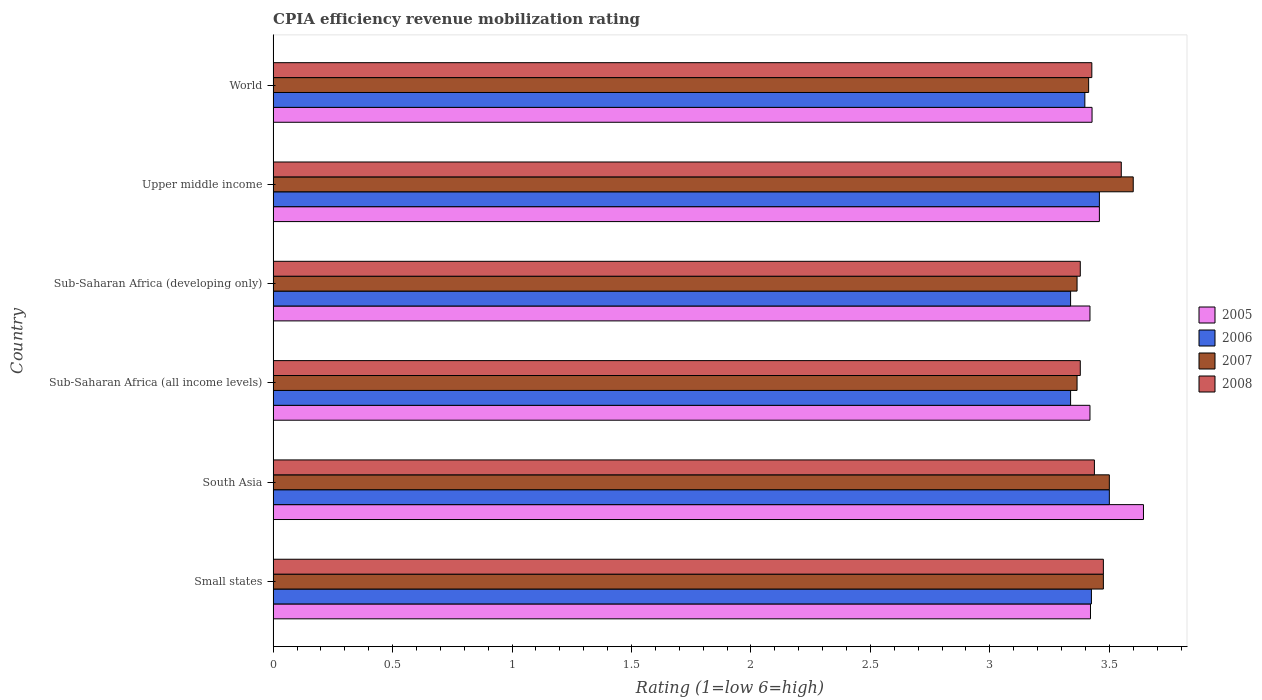How many groups of bars are there?
Provide a succinct answer. 6. Are the number of bars per tick equal to the number of legend labels?
Offer a very short reply. Yes. How many bars are there on the 5th tick from the top?
Keep it short and to the point. 4. What is the label of the 4th group of bars from the top?
Your answer should be very brief. Sub-Saharan Africa (all income levels). In how many cases, is the number of bars for a given country not equal to the number of legend labels?
Ensure brevity in your answer.  0. What is the CPIA rating in 2005 in Small states?
Provide a succinct answer. 3.42. Across all countries, what is the maximum CPIA rating in 2008?
Ensure brevity in your answer.  3.55. Across all countries, what is the minimum CPIA rating in 2008?
Provide a short and direct response. 3.38. In which country was the CPIA rating in 2007 maximum?
Your response must be concise. Upper middle income. In which country was the CPIA rating in 2008 minimum?
Your response must be concise. Sub-Saharan Africa (all income levels). What is the total CPIA rating in 2008 in the graph?
Your response must be concise. 20.65. What is the difference between the CPIA rating in 2007 in Small states and that in Sub-Saharan Africa (developing only)?
Provide a succinct answer. 0.11. What is the difference between the CPIA rating in 2008 in Small states and the CPIA rating in 2005 in Upper middle income?
Offer a very short reply. 0.02. What is the average CPIA rating in 2008 per country?
Keep it short and to the point. 3.44. What is the difference between the CPIA rating in 2007 and CPIA rating in 2005 in Small states?
Offer a terse response. 0.05. In how many countries, is the CPIA rating in 2006 greater than 1.3 ?
Make the answer very short. 6. What is the ratio of the CPIA rating in 2008 in South Asia to that in Sub-Saharan Africa (all income levels)?
Offer a terse response. 1.02. What is the difference between the highest and the second highest CPIA rating in 2008?
Keep it short and to the point. 0.07. What is the difference between the highest and the lowest CPIA rating in 2008?
Give a very brief answer. 0.17. In how many countries, is the CPIA rating in 2008 greater than the average CPIA rating in 2008 taken over all countries?
Offer a very short reply. 2. Is it the case that in every country, the sum of the CPIA rating in 2006 and CPIA rating in 2008 is greater than the sum of CPIA rating in 2007 and CPIA rating in 2005?
Make the answer very short. No. What does the 4th bar from the top in Sub-Saharan Africa (all income levels) represents?
Your response must be concise. 2005. What does the 3rd bar from the bottom in Small states represents?
Your response must be concise. 2007. Are all the bars in the graph horizontal?
Ensure brevity in your answer.  Yes. How many countries are there in the graph?
Make the answer very short. 6. What is the difference between two consecutive major ticks on the X-axis?
Offer a very short reply. 0.5. Are the values on the major ticks of X-axis written in scientific E-notation?
Give a very brief answer. No. Does the graph contain any zero values?
Your answer should be compact. No. Where does the legend appear in the graph?
Make the answer very short. Center right. How many legend labels are there?
Give a very brief answer. 4. What is the title of the graph?
Make the answer very short. CPIA efficiency revenue mobilization rating. Does "2009" appear as one of the legend labels in the graph?
Ensure brevity in your answer.  No. What is the Rating (1=low 6=high) in 2005 in Small states?
Make the answer very short. 3.42. What is the Rating (1=low 6=high) of 2006 in Small states?
Your answer should be compact. 3.42. What is the Rating (1=low 6=high) of 2007 in Small states?
Give a very brief answer. 3.48. What is the Rating (1=low 6=high) of 2008 in Small states?
Give a very brief answer. 3.48. What is the Rating (1=low 6=high) in 2005 in South Asia?
Provide a short and direct response. 3.64. What is the Rating (1=low 6=high) in 2006 in South Asia?
Provide a short and direct response. 3.5. What is the Rating (1=low 6=high) in 2008 in South Asia?
Ensure brevity in your answer.  3.44. What is the Rating (1=low 6=high) in 2005 in Sub-Saharan Africa (all income levels)?
Your response must be concise. 3.42. What is the Rating (1=low 6=high) of 2006 in Sub-Saharan Africa (all income levels)?
Your answer should be very brief. 3.34. What is the Rating (1=low 6=high) of 2007 in Sub-Saharan Africa (all income levels)?
Make the answer very short. 3.36. What is the Rating (1=low 6=high) in 2008 in Sub-Saharan Africa (all income levels)?
Provide a short and direct response. 3.38. What is the Rating (1=low 6=high) of 2005 in Sub-Saharan Africa (developing only)?
Give a very brief answer. 3.42. What is the Rating (1=low 6=high) of 2006 in Sub-Saharan Africa (developing only)?
Make the answer very short. 3.34. What is the Rating (1=low 6=high) of 2007 in Sub-Saharan Africa (developing only)?
Keep it short and to the point. 3.36. What is the Rating (1=low 6=high) of 2008 in Sub-Saharan Africa (developing only)?
Your answer should be compact. 3.38. What is the Rating (1=low 6=high) of 2005 in Upper middle income?
Provide a succinct answer. 3.46. What is the Rating (1=low 6=high) in 2006 in Upper middle income?
Give a very brief answer. 3.46. What is the Rating (1=low 6=high) in 2007 in Upper middle income?
Make the answer very short. 3.6. What is the Rating (1=low 6=high) in 2008 in Upper middle income?
Ensure brevity in your answer.  3.55. What is the Rating (1=low 6=high) in 2005 in World?
Your response must be concise. 3.43. What is the Rating (1=low 6=high) in 2006 in World?
Make the answer very short. 3.4. What is the Rating (1=low 6=high) in 2007 in World?
Give a very brief answer. 3.41. What is the Rating (1=low 6=high) in 2008 in World?
Ensure brevity in your answer.  3.43. Across all countries, what is the maximum Rating (1=low 6=high) in 2005?
Your answer should be very brief. 3.64. Across all countries, what is the maximum Rating (1=low 6=high) of 2006?
Your answer should be compact. 3.5. Across all countries, what is the maximum Rating (1=low 6=high) of 2007?
Ensure brevity in your answer.  3.6. Across all countries, what is the maximum Rating (1=low 6=high) of 2008?
Keep it short and to the point. 3.55. Across all countries, what is the minimum Rating (1=low 6=high) of 2005?
Give a very brief answer. 3.42. Across all countries, what is the minimum Rating (1=low 6=high) in 2006?
Give a very brief answer. 3.34. Across all countries, what is the minimum Rating (1=low 6=high) in 2007?
Offer a very short reply. 3.36. Across all countries, what is the minimum Rating (1=low 6=high) in 2008?
Offer a very short reply. 3.38. What is the total Rating (1=low 6=high) of 2005 in the graph?
Provide a short and direct response. 20.79. What is the total Rating (1=low 6=high) in 2006 in the graph?
Offer a terse response. 20.46. What is the total Rating (1=low 6=high) of 2007 in the graph?
Offer a terse response. 20.72. What is the total Rating (1=low 6=high) of 2008 in the graph?
Provide a succinct answer. 20.65. What is the difference between the Rating (1=low 6=high) of 2005 in Small states and that in South Asia?
Keep it short and to the point. -0.22. What is the difference between the Rating (1=low 6=high) in 2006 in Small states and that in South Asia?
Give a very brief answer. -0.07. What is the difference between the Rating (1=low 6=high) in 2007 in Small states and that in South Asia?
Offer a very short reply. -0.03. What is the difference between the Rating (1=low 6=high) in 2008 in Small states and that in South Asia?
Give a very brief answer. 0.04. What is the difference between the Rating (1=low 6=high) in 2005 in Small states and that in Sub-Saharan Africa (all income levels)?
Provide a short and direct response. 0. What is the difference between the Rating (1=low 6=high) in 2006 in Small states and that in Sub-Saharan Africa (all income levels)?
Provide a succinct answer. 0.09. What is the difference between the Rating (1=low 6=high) in 2007 in Small states and that in Sub-Saharan Africa (all income levels)?
Your answer should be very brief. 0.11. What is the difference between the Rating (1=low 6=high) of 2008 in Small states and that in Sub-Saharan Africa (all income levels)?
Give a very brief answer. 0.1. What is the difference between the Rating (1=low 6=high) of 2005 in Small states and that in Sub-Saharan Africa (developing only)?
Your answer should be compact. 0. What is the difference between the Rating (1=low 6=high) in 2006 in Small states and that in Sub-Saharan Africa (developing only)?
Make the answer very short. 0.09. What is the difference between the Rating (1=low 6=high) of 2007 in Small states and that in Sub-Saharan Africa (developing only)?
Provide a short and direct response. 0.11. What is the difference between the Rating (1=low 6=high) in 2008 in Small states and that in Sub-Saharan Africa (developing only)?
Give a very brief answer. 0.1. What is the difference between the Rating (1=low 6=high) in 2005 in Small states and that in Upper middle income?
Offer a terse response. -0.04. What is the difference between the Rating (1=low 6=high) of 2006 in Small states and that in Upper middle income?
Provide a short and direct response. -0.03. What is the difference between the Rating (1=low 6=high) in 2007 in Small states and that in Upper middle income?
Your answer should be very brief. -0.12. What is the difference between the Rating (1=low 6=high) in 2008 in Small states and that in Upper middle income?
Your answer should be compact. -0.07. What is the difference between the Rating (1=low 6=high) of 2005 in Small states and that in World?
Your answer should be very brief. -0.01. What is the difference between the Rating (1=low 6=high) of 2006 in Small states and that in World?
Your answer should be very brief. 0.03. What is the difference between the Rating (1=low 6=high) in 2007 in Small states and that in World?
Your answer should be compact. 0.06. What is the difference between the Rating (1=low 6=high) in 2008 in Small states and that in World?
Keep it short and to the point. 0.05. What is the difference between the Rating (1=low 6=high) of 2005 in South Asia and that in Sub-Saharan Africa (all income levels)?
Your response must be concise. 0.22. What is the difference between the Rating (1=low 6=high) in 2006 in South Asia and that in Sub-Saharan Africa (all income levels)?
Ensure brevity in your answer.  0.16. What is the difference between the Rating (1=low 6=high) in 2007 in South Asia and that in Sub-Saharan Africa (all income levels)?
Keep it short and to the point. 0.14. What is the difference between the Rating (1=low 6=high) of 2008 in South Asia and that in Sub-Saharan Africa (all income levels)?
Give a very brief answer. 0.06. What is the difference between the Rating (1=low 6=high) in 2005 in South Asia and that in Sub-Saharan Africa (developing only)?
Make the answer very short. 0.22. What is the difference between the Rating (1=low 6=high) in 2006 in South Asia and that in Sub-Saharan Africa (developing only)?
Your answer should be very brief. 0.16. What is the difference between the Rating (1=low 6=high) of 2007 in South Asia and that in Sub-Saharan Africa (developing only)?
Ensure brevity in your answer.  0.14. What is the difference between the Rating (1=low 6=high) in 2008 in South Asia and that in Sub-Saharan Africa (developing only)?
Keep it short and to the point. 0.06. What is the difference between the Rating (1=low 6=high) in 2005 in South Asia and that in Upper middle income?
Ensure brevity in your answer.  0.18. What is the difference between the Rating (1=low 6=high) in 2006 in South Asia and that in Upper middle income?
Your answer should be very brief. 0.04. What is the difference between the Rating (1=low 6=high) of 2008 in South Asia and that in Upper middle income?
Provide a succinct answer. -0.11. What is the difference between the Rating (1=low 6=high) of 2005 in South Asia and that in World?
Keep it short and to the point. 0.22. What is the difference between the Rating (1=low 6=high) of 2006 in South Asia and that in World?
Your answer should be compact. 0.1. What is the difference between the Rating (1=low 6=high) in 2007 in South Asia and that in World?
Your answer should be compact. 0.09. What is the difference between the Rating (1=low 6=high) of 2008 in South Asia and that in World?
Ensure brevity in your answer.  0.01. What is the difference between the Rating (1=low 6=high) in 2006 in Sub-Saharan Africa (all income levels) and that in Sub-Saharan Africa (developing only)?
Ensure brevity in your answer.  0. What is the difference between the Rating (1=low 6=high) in 2008 in Sub-Saharan Africa (all income levels) and that in Sub-Saharan Africa (developing only)?
Provide a succinct answer. 0. What is the difference between the Rating (1=low 6=high) in 2005 in Sub-Saharan Africa (all income levels) and that in Upper middle income?
Keep it short and to the point. -0.04. What is the difference between the Rating (1=low 6=high) in 2006 in Sub-Saharan Africa (all income levels) and that in Upper middle income?
Keep it short and to the point. -0.12. What is the difference between the Rating (1=low 6=high) of 2007 in Sub-Saharan Africa (all income levels) and that in Upper middle income?
Your answer should be compact. -0.24. What is the difference between the Rating (1=low 6=high) of 2008 in Sub-Saharan Africa (all income levels) and that in Upper middle income?
Offer a terse response. -0.17. What is the difference between the Rating (1=low 6=high) in 2005 in Sub-Saharan Africa (all income levels) and that in World?
Your response must be concise. -0.01. What is the difference between the Rating (1=low 6=high) in 2006 in Sub-Saharan Africa (all income levels) and that in World?
Provide a short and direct response. -0.06. What is the difference between the Rating (1=low 6=high) of 2007 in Sub-Saharan Africa (all income levels) and that in World?
Your answer should be very brief. -0.05. What is the difference between the Rating (1=low 6=high) in 2008 in Sub-Saharan Africa (all income levels) and that in World?
Make the answer very short. -0.05. What is the difference between the Rating (1=low 6=high) of 2005 in Sub-Saharan Africa (developing only) and that in Upper middle income?
Your response must be concise. -0.04. What is the difference between the Rating (1=low 6=high) in 2006 in Sub-Saharan Africa (developing only) and that in Upper middle income?
Offer a very short reply. -0.12. What is the difference between the Rating (1=low 6=high) in 2007 in Sub-Saharan Africa (developing only) and that in Upper middle income?
Keep it short and to the point. -0.24. What is the difference between the Rating (1=low 6=high) of 2008 in Sub-Saharan Africa (developing only) and that in Upper middle income?
Offer a very short reply. -0.17. What is the difference between the Rating (1=low 6=high) in 2005 in Sub-Saharan Africa (developing only) and that in World?
Offer a very short reply. -0.01. What is the difference between the Rating (1=low 6=high) of 2006 in Sub-Saharan Africa (developing only) and that in World?
Provide a short and direct response. -0.06. What is the difference between the Rating (1=low 6=high) in 2007 in Sub-Saharan Africa (developing only) and that in World?
Give a very brief answer. -0.05. What is the difference between the Rating (1=low 6=high) in 2008 in Sub-Saharan Africa (developing only) and that in World?
Make the answer very short. -0.05. What is the difference between the Rating (1=low 6=high) of 2005 in Upper middle income and that in World?
Your answer should be compact. 0.03. What is the difference between the Rating (1=low 6=high) of 2006 in Upper middle income and that in World?
Offer a very short reply. 0.06. What is the difference between the Rating (1=low 6=high) in 2007 in Upper middle income and that in World?
Your answer should be very brief. 0.19. What is the difference between the Rating (1=low 6=high) of 2008 in Upper middle income and that in World?
Give a very brief answer. 0.12. What is the difference between the Rating (1=low 6=high) of 2005 in Small states and the Rating (1=low 6=high) of 2006 in South Asia?
Provide a succinct answer. -0.08. What is the difference between the Rating (1=low 6=high) of 2005 in Small states and the Rating (1=low 6=high) of 2007 in South Asia?
Your answer should be compact. -0.08. What is the difference between the Rating (1=low 6=high) of 2005 in Small states and the Rating (1=low 6=high) of 2008 in South Asia?
Provide a succinct answer. -0.02. What is the difference between the Rating (1=low 6=high) in 2006 in Small states and the Rating (1=low 6=high) in 2007 in South Asia?
Your answer should be compact. -0.07. What is the difference between the Rating (1=low 6=high) in 2006 in Small states and the Rating (1=low 6=high) in 2008 in South Asia?
Provide a short and direct response. -0.01. What is the difference between the Rating (1=low 6=high) of 2007 in Small states and the Rating (1=low 6=high) of 2008 in South Asia?
Ensure brevity in your answer.  0.04. What is the difference between the Rating (1=low 6=high) in 2005 in Small states and the Rating (1=low 6=high) in 2006 in Sub-Saharan Africa (all income levels)?
Offer a terse response. 0.08. What is the difference between the Rating (1=low 6=high) in 2005 in Small states and the Rating (1=low 6=high) in 2007 in Sub-Saharan Africa (all income levels)?
Ensure brevity in your answer.  0.06. What is the difference between the Rating (1=low 6=high) in 2005 in Small states and the Rating (1=low 6=high) in 2008 in Sub-Saharan Africa (all income levels)?
Ensure brevity in your answer.  0.04. What is the difference between the Rating (1=low 6=high) of 2006 in Small states and the Rating (1=low 6=high) of 2007 in Sub-Saharan Africa (all income levels)?
Provide a succinct answer. 0.06. What is the difference between the Rating (1=low 6=high) of 2006 in Small states and the Rating (1=low 6=high) of 2008 in Sub-Saharan Africa (all income levels)?
Offer a terse response. 0.05. What is the difference between the Rating (1=low 6=high) of 2007 in Small states and the Rating (1=low 6=high) of 2008 in Sub-Saharan Africa (all income levels)?
Provide a short and direct response. 0.1. What is the difference between the Rating (1=low 6=high) of 2005 in Small states and the Rating (1=low 6=high) of 2006 in Sub-Saharan Africa (developing only)?
Ensure brevity in your answer.  0.08. What is the difference between the Rating (1=low 6=high) in 2005 in Small states and the Rating (1=low 6=high) in 2007 in Sub-Saharan Africa (developing only)?
Your response must be concise. 0.06. What is the difference between the Rating (1=low 6=high) of 2005 in Small states and the Rating (1=low 6=high) of 2008 in Sub-Saharan Africa (developing only)?
Offer a terse response. 0.04. What is the difference between the Rating (1=low 6=high) in 2006 in Small states and the Rating (1=low 6=high) in 2007 in Sub-Saharan Africa (developing only)?
Your answer should be compact. 0.06. What is the difference between the Rating (1=low 6=high) of 2006 in Small states and the Rating (1=low 6=high) of 2008 in Sub-Saharan Africa (developing only)?
Give a very brief answer. 0.05. What is the difference between the Rating (1=low 6=high) in 2007 in Small states and the Rating (1=low 6=high) in 2008 in Sub-Saharan Africa (developing only)?
Offer a very short reply. 0.1. What is the difference between the Rating (1=low 6=high) in 2005 in Small states and the Rating (1=low 6=high) in 2006 in Upper middle income?
Provide a succinct answer. -0.04. What is the difference between the Rating (1=low 6=high) of 2005 in Small states and the Rating (1=low 6=high) of 2007 in Upper middle income?
Ensure brevity in your answer.  -0.18. What is the difference between the Rating (1=low 6=high) of 2005 in Small states and the Rating (1=low 6=high) of 2008 in Upper middle income?
Your response must be concise. -0.13. What is the difference between the Rating (1=low 6=high) of 2006 in Small states and the Rating (1=low 6=high) of 2007 in Upper middle income?
Keep it short and to the point. -0.17. What is the difference between the Rating (1=low 6=high) in 2006 in Small states and the Rating (1=low 6=high) in 2008 in Upper middle income?
Offer a terse response. -0.12. What is the difference between the Rating (1=low 6=high) of 2007 in Small states and the Rating (1=low 6=high) of 2008 in Upper middle income?
Your answer should be very brief. -0.07. What is the difference between the Rating (1=low 6=high) in 2005 in Small states and the Rating (1=low 6=high) in 2006 in World?
Offer a very short reply. 0.02. What is the difference between the Rating (1=low 6=high) in 2005 in Small states and the Rating (1=low 6=high) in 2007 in World?
Offer a very short reply. 0.01. What is the difference between the Rating (1=low 6=high) in 2005 in Small states and the Rating (1=low 6=high) in 2008 in World?
Provide a short and direct response. -0.01. What is the difference between the Rating (1=low 6=high) in 2006 in Small states and the Rating (1=low 6=high) in 2007 in World?
Offer a terse response. 0.01. What is the difference between the Rating (1=low 6=high) of 2006 in Small states and the Rating (1=low 6=high) of 2008 in World?
Ensure brevity in your answer.  -0. What is the difference between the Rating (1=low 6=high) in 2007 in Small states and the Rating (1=low 6=high) in 2008 in World?
Offer a terse response. 0.05. What is the difference between the Rating (1=low 6=high) in 2005 in South Asia and the Rating (1=low 6=high) in 2006 in Sub-Saharan Africa (all income levels)?
Give a very brief answer. 0.3. What is the difference between the Rating (1=low 6=high) in 2005 in South Asia and the Rating (1=low 6=high) in 2007 in Sub-Saharan Africa (all income levels)?
Provide a short and direct response. 0.28. What is the difference between the Rating (1=low 6=high) in 2005 in South Asia and the Rating (1=low 6=high) in 2008 in Sub-Saharan Africa (all income levels)?
Provide a short and direct response. 0.26. What is the difference between the Rating (1=low 6=high) of 2006 in South Asia and the Rating (1=low 6=high) of 2007 in Sub-Saharan Africa (all income levels)?
Ensure brevity in your answer.  0.14. What is the difference between the Rating (1=low 6=high) in 2006 in South Asia and the Rating (1=low 6=high) in 2008 in Sub-Saharan Africa (all income levels)?
Make the answer very short. 0.12. What is the difference between the Rating (1=low 6=high) in 2007 in South Asia and the Rating (1=low 6=high) in 2008 in Sub-Saharan Africa (all income levels)?
Your response must be concise. 0.12. What is the difference between the Rating (1=low 6=high) in 2005 in South Asia and the Rating (1=low 6=high) in 2006 in Sub-Saharan Africa (developing only)?
Your response must be concise. 0.3. What is the difference between the Rating (1=low 6=high) in 2005 in South Asia and the Rating (1=low 6=high) in 2007 in Sub-Saharan Africa (developing only)?
Your answer should be compact. 0.28. What is the difference between the Rating (1=low 6=high) in 2005 in South Asia and the Rating (1=low 6=high) in 2008 in Sub-Saharan Africa (developing only)?
Offer a terse response. 0.26. What is the difference between the Rating (1=low 6=high) in 2006 in South Asia and the Rating (1=low 6=high) in 2007 in Sub-Saharan Africa (developing only)?
Ensure brevity in your answer.  0.14. What is the difference between the Rating (1=low 6=high) of 2006 in South Asia and the Rating (1=low 6=high) of 2008 in Sub-Saharan Africa (developing only)?
Keep it short and to the point. 0.12. What is the difference between the Rating (1=low 6=high) of 2007 in South Asia and the Rating (1=low 6=high) of 2008 in Sub-Saharan Africa (developing only)?
Offer a terse response. 0.12. What is the difference between the Rating (1=low 6=high) of 2005 in South Asia and the Rating (1=low 6=high) of 2006 in Upper middle income?
Give a very brief answer. 0.18. What is the difference between the Rating (1=low 6=high) in 2005 in South Asia and the Rating (1=low 6=high) in 2007 in Upper middle income?
Provide a succinct answer. 0.04. What is the difference between the Rating (1=low 6=high) in 2005 in South Asia and the Rating (1=low 6=high) in 2008 in Upper middle income?
Make the answer very short. 0.09. What is the difference between the Rating (1=low 6=high) in 2006 in South Asia and the Rating (1=low 6=high) in 2007 in Upper middle income?
Your response must be concise. -0.1. What is the difference between the Rating (1=low 6=high) of 2005 in South Asia and the Rating (1=low 6=high) of 2006 in World?
Provide a succinct answer. 0.25. What is the difference between the Rating (1=low 6=high) of 2005 in South Asia and the Rating (1=low 6=high) of 2007 in World?
Your answer should be very brief. 0.23. What is the difference between the Rating (1=low 6=high) in 2005 in South Asia and the Rating (1=low 6=high) in 2008 in World?
Make the answer very short. 0.22. What is the difference between the Rating (1=low 6=high) of 2006 in South Asia and the Rating (1=low 6=high) of 2007 in World?
Give a very brief answer. 0.09. What is the difference between the Rating (1=low 6=high) of 2006 in South Asia and the Rating (1=low 6=high) of 2008 in World?
Your response must be concise. 0.07. What is the difference between the Rating (1=low 6=high) in 2007 in South Asia and the Rating (1=low 6=high) in 2008 in World?
Make the answer very short. 0.07. What is the difference between the Rating (1=low 6=high) of 2005 in Sub-Saharan Africa (all income levels) and the Rating (1=low 6=high) of 2006 in Sub-Saharan Africa (developing only)?
Offer a terse response. 0.08. What is the difference between the Rating (1=low 6=high) in 2005 in Sub-Saharan Africa (all income levels) and the Rating (1=low 6=high) in 2007 in Sub-Saharan Africa (developing only)?
Offer a terse response. 0.05. What is the difference between the Rating (1=low 6=high) of 2005 in Sub-Saharan Africa (all income levels) and the Rating (1=low 6=high) of 2008 in Sub-Saharan Africa (developing only)?
Keep it short and to the point. 0.04. What is the difference between the Rating (1=low 6=high) in 2006 in Sub-Saharan Africa (all income levels) and the Rating (1=low 6=high) in 2007 in Sub-Saharan Africa (developing only)?
Your response must be concise. -0.03. What is the difference between the Rating (1=low 6=high) of 2006 in Sub-Saharan Africa (all income levels) and the Rating (1=low 6=high) of 2008 in Sub-Saharan Africa (developing only)?
Ensure brevity in your answer.  -0.04. What is the difference between the Rating (1=low 6=high) in 2007 in Sub-Saharan Africa (all income levels) and the Rating (1=low 6=high) in 2008 in Sub-Saharan Africa (developing only)?
Keep it short and to the point. -0.01. What is the difference between the Rating (1=low 6=high) in 2005 in Sub-Saharan Africa (all income levels) and the Rating (1=low 6=high) in 2006 in Upper middle income?
Give a very brief answer. -0.04. What is the difference between the Rating (1=low 6=high) of 2005 in Sub-Saharan Africa (all income levels) and the Rating (1=low 6=high) of 2007 in Upper middle income?
Provide a succinct answer. -0.18. What is the difference between the Rating (1=low 6=high) in 2005 in Sub-Saharan Africa (all income levels) and the Rating (1=low 6=high) in 2008 in Upper middle income?
Provide a short and direct response. -0.13. What is the difference between the Rating (1=low 6=high) of 2006 in Sub-Saharan Africa (all income levels) and the Rating (1=low 6=high) of 2007 in Upper middle income?
Provide a succinct answer. -0.26. What is the difference between the Rating (1=low 6=high) of 2006 in Sub-Saharan Africa (all income levels) and the Rating (1=low 6=high) of 2008 in Upper middle income?
Provide a short and direct response. -0.21. What is the difference between the Rating (1=low 6=high) in 2007 in Sub-Saharan Africa (all income levels) and the Rating (1=low 6=high) in 2008 in Upper middle income?
Make the answer very short. -0.19. What is the difference between the Rating (1=low 6=high) in 2005 in Sub-Saharan Africa (all income levels) and the Rating (1=low 6=high) in 2006 in World?
Make the answer very short. 0.02. What is the difference between the Rating (1=low 6=high) of 2005 in Sub-Saharan Africa (all income levels) and the Rating (1=low 6=high) of 2007 in World?
Offer a very short reply. 0.01. What is the difference between the Rating (1=low 6=high) in 2005 in Sub-Saharan Africa (all income levels) and the Rating (1=low 6=high) in 2008 in World?
Your answer should be compact. -0.01. What is the difference between the Rating (1=low 6=high) in 2006 in Sub-Saharan Africa (all income levels) and the Rating (1=low 6=high) in 2007 in World?
Provide a short and direct response. -0.08. What is the difference between the Rating (1=low 6=high) in 2006 in Sub-Saharan Africa (all income levels) and the Rating (1=low 6=high) in 2008 in World?
Offer a terse response. -0.09. What is the difference between the Rating (1=low 6=high) in 2007 in Sub-Saharan Africa (all income levels) and the Rating (1=low 6=high) in 2008 in World?
Offer a terse response. -0.06. What is the difference between the Rating (1=low 6=high) in 2005 in Sub-Saharan Africa (developing only) and the Rating (1=low 6=high) in 2006 in Upper middle income?
Keep it short and to the point. -0.04. What is the difference between the Rating (1=low 6=high) in 2005 in Sub-Saharan Africa (developing only) and the Rating (1=low 6=high) in 2007 in Upper middle income?
Your answer should be compact. -0.18. What is the difference between the Rating (1=low 6=high) in 2005 in Sub-Saharan Africa (developing only) and the Rating (1=low 6=high) in 2008 in Upper middle income?
Make the answer very short. -0.13. What is the difference between the Rating (1=low 6=high) of 2006 in Sub-Saharan Africa (developing only) and the Rating (1=low 6=high) of 2007 in Upper middle income?
Your answer should be very brief. -0.26. What is the difference between the Rating (1=low 6=high) in 2006 in Sub-Saharan Africa (developing only) and the Rating (1=low 6=high) in 2008 in Upper middle income?
Ensure brevity in your answer.  -0.21. What is the difference between the Rating (1=low 6=high) in 2007 in Sub-Saharan Africa (developing only) and the Rating (1=low 6=high) in 2008 in Upper middle income?
Provide a short and direct response. -0.19. What is the difference between the Rating (1=low 6=high) of 2005 in Sub-Saharan Africa (developing only) and the Rating (1=low 6=high) of 2006 in World?
Provide a short and direct response. 0.02. What is the difference between the Rating (1=low 6=high) in 2005 in Sub-Saharan Africa (developing only) and the Rating (1=low 6=high) in 2007 in World?
Provide a succinct answer. 0.01. What is the difference between the Rating (1=low 6=high) in 2005 in Sub-Saharan Africa (developing only) and the Rating (1=low 6=high) in 2008 in World?
Make the answer very short. -0.01. What is the difference between the Rating (1=low 6=high) in 2006 in Sub-Saharan Africa (developing only) and the Rating (1=low 6=high) in 2007 in World?
Your answer should be compact. -0.08. What is the difference between the Rating (1=low 6=high) in 2006 in Sub-Saharan Africa (developing only) and the Rating (1=low 6=high) in 2008 in World?
Offer a terse response. -0.09. What is the difference between the Rating (1=low 6=high) of 2007 in Sub-Saharan Africa (developing only) and the Rating (1=low 6=high) of 2008 in World?
Your answer should be very brief. -0.06. What is the difference between the Rating (1=low 6=high) of 2005 in Upper middle income and the Rating (1=low 6=high) of 2006 in World?
Make the answer very short. 0.06. What is the difference between the Rating (1=low 6=high) of 2005 in Upper middle income and the Rating (1=low 6=high) of 2007 in World?
Give a very brief answer. 0.04. What is the difference between the Rating (1=low 6=high) in 2005 in Upper middle income and the Rating (1=low 6=high) in 2008 in World?
Provide a succinct answer. 0.03. What is the difference between the Rating (1=low 6=high) in 2006 in Upper middle income and the Rating (1=low 6=high) in 2007 in World?
Ensure brevity in your answer.  0.04. What is the difference between the Rating (1=low 6=high) of 2006 in Upper middle income and the Rating (1=low 6=high) of 2008 in World?
Give a very brief answer. 0.03. What is the difference between the Rating (1=low 6=high) in 2007 in Upper middle income and the Rating (1=low 6=high) in 2008 in World?
Provide a short and direct response. 0.17. What is the average Rating (1=low 6=high) in 2005 per country?
Offer a very short reply. 3.46. What is the average Rating (1=low 6=high) in 2006 per country?
Provide a short and direct response. 3.41. What is the average Rating (1=low 6=high) in 2007 per country?
Provide a short and direct response. 3.45. What is the average Rating (1=low 6=high) of 2008 per country?
Provide a short and direct response. 3.44. What is the difference between the Rating (1=low 6=high) of 2005 and Rating (1=low 6=high) of 2006 in Small states?
Make the answer very short. -0. What is the difference between the Rating (1=low 6=high) in 2005 and Rating (1=low 6=high) in 2007 in Small states?
Make the answer very short. -0.05. What is the difference between the Rating (1=low 6=high) of 2005 and Rating (1=low 6=high) of 2008 in Small states?
Keep it short and to the point. -0.05. What is the difference between the Rating (1=low 6=high) of 2006 and Rating (1=low 6=high) of 2007 in Small states?
Your answer should be compact. -0.05. What is the difference between the Rating (1=low 6=high) in 2007 and Rating (1=low 6=high) in 2008 in Small states?
Provide a succinct answer. 0. What is the difference between the Rating (1=low 6=high) of 2005 and Rating (1=low 6=high) of 2006 in South Asia?
Provide a succinct answer. 0.14. What is the difference between the Rating (1=low 6=high) in 2005 and Rating (1=low 6=high) in 2007 in South Asia?
Provide a short and direct response. 0.14. What is the difference between the Rating (1=low 6=high) of 2005 and Rating (1=low 6=high) of 2008 in South Asia?
Make the answer very short. 0.21. What is the difference between the Rating (1=low 6=high) of 2006 and Rating (1=low 6=high) of 2007 in South Asia?
Provide a short and direct response. 0. What is the difference between the Rating (1=low 6=high) of 2006 and Rating (1=low 6=high) of 2008 in South Asia?
Provide a short and direct response. 0.06. What is the difference between the Rating (1=low 6=high) in 2007 and Rating (1=low 6=high) in 2008 in South Asia?
Provide a succinct answer. 0.06. What is the difference between the Rating (1=low 6=high) of 2005 and Rating (1=low 6=high) of 2006 in Sub-Saharan Africa (all income levels)?
Provide a short and direct response. 0.08. What is the difference between the Rating (1=low 6=high) in 2005 and Rating (1=low 6=high) in 2007 in Sub-Saharan Africa (all income levels)?
Your response must be concise. 0.05. What is the difference between the Rating (1=low 6=high) in 2005 and Rating (1=low 6=high) in 2008 in Sub-Saharan Africa (all income levels)?
Keep it short and to the point. 0.04. What is the difference between the Rating (1=low 6=high) of 2006 and Rating (1=low 6=high) of 2007 in Sub-Saharan Africa (all income levels)?
Provide a short and direct response. -0.03. What is the difference between the Rating (1=low 6=high) of 2006 and Rating (1=low 6=high) of 2008 in Sub-Saharan Africa (all income levels)?
Your answer should be compact. -0.04. What is the difference between the Rating (1=low 6=high) of 2007 and Rating (1=low 6=high) of 2008 in Sub-Saharan Africa (all income levels)?
Provide a short and direct response. -0.01. What is the difference between the Rating (1=low 6=high) in 2005 and Rating (1=low 6=high) in 2006 in Sub-Saharan Africa (developing only)?
Give a very brief answer. 0.08. What is the difference between the Rating (1=low 6=high) of 2005 and Rating (1=low 6=high) of 2007 in Sub-Saharan Africa (developing only)?
Your answer should be very brief. 0.05. What is the difference between the Rating (1=low 6=high) in 2005 and Rating (1=low 6=high) in 2008 in Sub-Saharan Africa (developing only)?
Provide a succinct answer. 0.04. What is the difference between the Rating (1=low 6=high) of 2006 and Rating (1=low 6=high) of 2007 in Sub-Saharan Africa (developing only)?
Your answer should be compact. -0.03. What is the difference between the Rating (1=low 6=high) in 2006 and Rating (1=low 6=high) in 2008 in Sub-Saharan Africa (developing only)?
Your answer should be very brief. -0.04. What is the difference between the Rating (1=low 6=high) of 2007 and Rating (1=low 6=high) of 2008 in Sub-Saharan Africa (developing only)?
Keep it short and to the point. -0.01. What is the difference between the Rating (1=low 6=high) of 2005 and Rating (1=low 6=high) of 2007 in Upper middle income?
Your response must be concise. -0.14. What is the difference between the Rating (1=low 6=high) of 2005 and Rating (1=low 6=high) of 2008 in Upper middle income?
Keep it short and to the point. -0.09. What is the difference between the Rating (1=low 6=high) in 2006 and Rating (1=low 6=high) in 2007 in Upper middle income?
Ensure brevity in your answer.  -0.14. What is the difference between the Rating (1=low 6=high) of 2006 and Rating (1=low 6=high) of 2008 in Upper middle income?
Give a very brief answer. -0.09. What is the difference between the Rating (1=low 6=high) in 2007 and Rating (1=low 6=high) in 2008 in Upper middle income?
Make the answer very short. 0.05. What is the difference between the Rating (1=low 6=high) in 2005 and Rating (1=low 6=high) in 2006 in World?
Your response must be concise. 0.03. What is the difference between the Rating (1=low 6=high) of 2005 and Rating (1=low 6=high) of 2007 in World?
Keep it short and to the point. 0.01. What is the difference between the Rating (1=low 6=high) of 2006 and Rating (1=low 6=high) of 2007 in World?
Keep it short and to the point. -0.02. What is the difference between the Rating (1=low 6=high) in 2006 and Rating (1=low 6=high) in 2008 in World?
Your response must be concise. -0.03. What is the difference between the Rating (1=low 6=high) of 2007 and Rating (1=low 6=high) of 2008 in World?
Provide a succinct answer. -0.01. What is the ratio of the Rating (1=low 6=high) in 2005 in Small states to that in South Asia?
Provide a short and direct response. 0.94. What is the ratio of the Rating (1=low 6=high) of 2006 in Small states to that in South Asia?
Provide a succinct answer. 0.98. What is the ratio of the Rating (1=low 6=high) of 2008 in Small states to that in South Asia?
Give a very brief answer. 1.01. What is the ratio of the Rating (1=low 6=high) of 2005 in Small states to that in Sub-Saharan Africa (all income levels)?
Your response must be concise. 1. What is the ratio of the Rating (1=low 6=high) of 2006 in Small states to that in Sub-Saharan Africa (all income levels)?
Provide a short and direct response. 1.03. What is the ratio of the Rating (1=low 6=high) in 2007 in Small states to that in Sub-Saharan Africa (all income levels)?
Give a very brief answer. 1.03. What is the ratio of the Rating (1=low 6=high) of 2008 in Small states to that in Sub-Saharan Africa (all income levels)?
Your answer should be very brief. 1.03. What is the ratio of the Rating (1=low 6=high) of 2005 in Small states to that in Sub-Saharan Africa (developing only)?
Keep it short and to the point. 1. What is the ratio of the Rating (1=low 6=high) in 2006 in Small states to that in Sub-Saharan Africa (developing only)?
Ensure brevity in your answer.  1.03. What is the ratio of the Rating (1=low 6=high) in 2007 in Small states to that in Sub-Saharan Africa (developing only)?
Keep it short and to the point. 1.03. What is the ratio of the Rating (1=low 6=high) of 2008 in Small states to that in Sub-Saharan Africa (developing only)?
Provide a succinct answer. 1.03. What is the ratio of the Rating (1=low 6=high) in 2005 in Small states to that in Upper middle income?
Provide a short and direct response. 0.99. What is the ratio of the Rating (1=low 6=high) of 2006 in Small states to that in Upper middle income?
Provide a short and direct response. 0.99. What is the ratio of the Rating (1=low 6=high) in 2007 in Small states to that in Upper middle income?
Your answer should be compact. 0.97. What is the ratio of the Rating (1=low 6=high) of 2008 in Small states to that in Upper middle income?
Provide a short and direct response. 0.98. What is the ratio of the Rating (1=low 6=high) in 2007 in Small states to that in World?
Offer a very short reply. 1.02. What is the ratio of the Rating (1=low 6=high) of 2008 in Small states to that in World?
Your answer should be compact. 1.01. What is the ratio of the Rating (1=low 6=high) of 2005 in South Asia to that in Sub-Saharan Africa (all income levels)?
Ensure brevity in your answer.  1.07. What is the ratio of the Rating (1=low 6=high) of 2006 in South Asia to that in Sub-Saharan Africa (all income levels)?
Your response must be concise. 1.05. What is the ratio of the Rating (1=low 6=high) in 2007 in South Asia to that in Sub-Saharan Africa (all income levels)?
Provide a short and direct response. 1.04. What is the ratio of the Rating (1=low 6=high) of 2008 in South Asia to that in Sub-Saharan Africa (all income levels)?
Provide a short and direct response. 1.02. What is the ratio of the Rating (1=low 6=high) of 2005 in South Asia to that in Sub-Saharan Africa (developing only)?
Provide a short and direct response. 1.07. What is the ratio of the Rating (1=low 6=high) of 2006 in South Asia to that in Sub-Saharan Africa (developing only)?
Make the answer very short. 1.05. What is the ratio of the Rating (1=low 6=high) of 2007 in South Asia to that in Sub-Saharan Africa (developing only)?
Offer a terse response. 1.04. What is the ratio of the Rating (1=low 6=high) of 2008 in South Asia to that in Sub-Saharan Africa (developing only)?
Make the answer very short. 1.02. What is the ratio of the Rating (1=low 6=high) of 2005 in South Asia to that in Upper middle income?
Your answer should be very brief. 1.05. What is the ratio of the Rating (1=low 6=high) of 2007 in South Asia to that in Upper middle income?
Offer a terse response. 0.97. What is the ratio of the Rating (1=low 6=high) of 2008 in South Asia to that in Upper middle income?
Offer a terse response. 0.97. What is the ratio of the Rating (1=low 6=high) of 2005 in South Asia to that in World?
Provide a succinct answer. 1.06. What is the ratio of the Rating (1=low 6=high) in 2006 in South Asia to that in World?
Your answer should be very brief. 1.03. What is the ratio of the Rating (1=low 6=high) of 2007 in South Asia to that in World?
Provide a succinct answer. 1.03. What is the ratio of the Rating (1=low 6=high) of 2008 in South Asia to that in World?
Give a very brief answer. 1. What is the ratio of the Rating (1=low 6=high) in 2005 in Sub-Saharan Africa (all income levels) to that in Sub-Saharan Africa (developing only)?
Your response must be concise. 1. What is the ratio of the Rating (1=low 6=high) in 2006 in Sub-Saharan Africa (all income levels) to that in Sub-Saharan Africa (developing only)?
Offer a terse response. 1. What is the ratio of the Rating (1=low 6=high) of 2007 in Sub-Saharan Africa (all income levels) to that in Sub-Saharan Africa (developing only)?
Provide a short and direct response. 1. What is the ratio of the Rating (1=low 6=high) of 2008 in Sub-Saharan Africa (all income levels) to that in Sub-Saharan Africa (developing only)?
Give a very brief answer. 1. What is the ratio of the Rating (1=low 6=high) of 2005 in Sub-Saharan Africa (all income levels) to that in Upper middle income?
Your answer should be compact. 0.99. What is the ratio of the Rating (1=low 6=high) of 2006 in Sub-Saharan Africa (all income levels) to that in Upper middle income?
Provide a succinct answer. 0.97. What is the ratio of the Rating (1=low 6=high) in 2007 in Sub-Saharan Africa (all income levels) to that in Upper middle income?
Your answer should be compact. 0.93. What is the ratio of the Rating (1=low 6=high) of 2008 in Sub-Saharan Africa (all income levels) to that in Upper middle income?
Ensure brevity in your answer.  0.95. What is the ratio of the Rating (1=low 6=high) in 2006 in Sub-Saharan Africa (all income levels) to that in World?
Your answer should be compact. 0.98. What is the ratio of the Rating (1=low 6=high) in 2007 in Sub-Saharan Africa (all income levels) to that in World?
Your answer should be very brief. 0.99. What is the ratio of the Rating (1=low 6=high) in 2008 in Sub-Saharan Africa (all income levels) to that in World?
Offer a very short reply. 0.99. What is the ratio of the Rating (1=low 6=high) in 2005 in Sub-Saharan Africa (developing only) to that in Upper middle income?
Keep it short and to the point. 0.99. What is the ratio of the Rating (1=low 6=high) of 2006 in Sub-Saharan Africa (developing only) to that in Upper middle income?
Make the answer very short. 0.97. What is the ratio of the Rating (1=low 6=high) of 2007 in Sub-Saharan Africa (developing only) to that in Upper middle income?
Provide a short and direct response. 0.93. What is the ratio of the Rating (1=low 6=high) in 2008 in Sub-Saharan Africa (developing only) to that in Upper middle income?
Your answer should be compact. 0.95. What is the ratio of the Rating (1=low 6=high) in 2006 in Sub-Saharan Africa (developing only) to that in World?
Your answer should be very brief. 0.98. What is the ratio of the Rating (1=low 6=high) of 2007 in Sub-Saharan Africa (developing only) to that in World?
Give a very brief answer. 0.99. What is the ratio of the Rating (1=low 6=high) in 2008 in Sub-Saharan Africa (developing only) to that in World?
Your answer should be compact. 0.99. What is the ratio of the Rating (1=low 6=high) of 2006 in Upper middle income to that in World?
Your response must be concise. 1.02. What is the ratio of the Rating (1=low 6=high) in 2007 in Upper middle income to that in World?
Ensure brevity in your answer.  1.05. What is the ratio of the Rating (1=low 6=high) in 2008 in Upper middle income to that in World?
Give a very brief answer. 1.04. What is the difference between the highest and the second highest Rating (1=low 6=high) of 2005?
Give a very brief answer. 0.18. What is the difference between the highest and the second highest Rating (1=low 6=high) in 2006?
Your answer should be very brief. 0.04. What is the difference between the highest and the second highest Rating (1=low 6=high) in 2007?
Offer a very short reply. 0.1. What is the difference between the highest and the second highest Rating (1=low 6=high) of 2008?
Give a very brief answer. 0.07. What is the difference between the highest and the lowest Rating (1=low 6=high) in 2005?
Give a very brief answer. 0.22. What is the difference between the highest and the lowest Rating (1=low 6=high) of 2006?
Offer a very short reply. 0.16. What is the difference between the highest and the lowest Rating (1=low 6=high) of 2007?
Provide a short and direct response. 0.24. What is the difference between the highest and the lowest Rating (1=low 6=high) of 2008?
Provide a short and direct response. 0.17. 